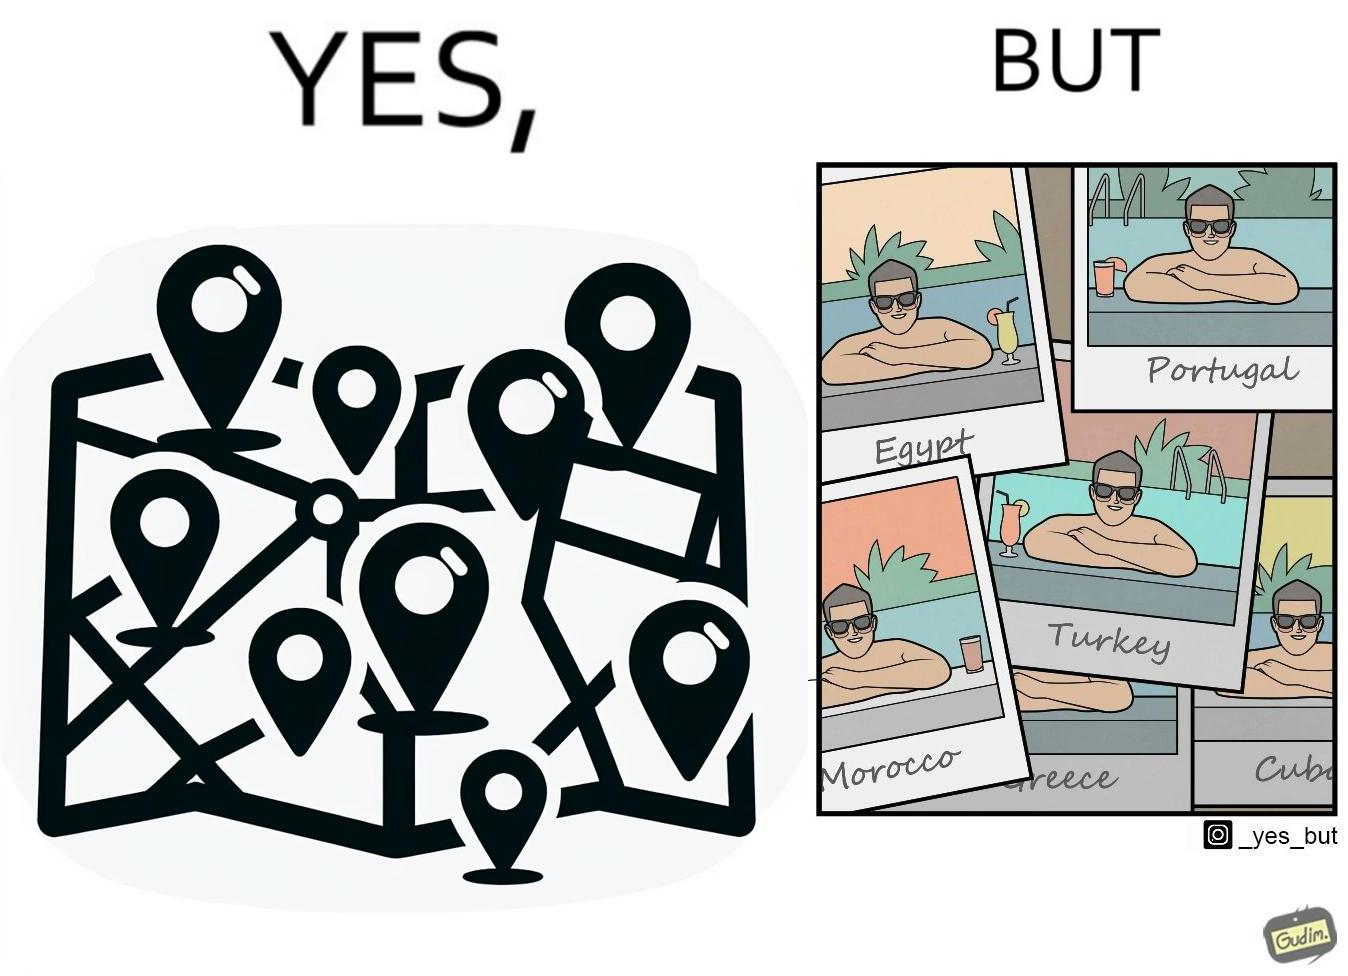What is the satirical meaning behind this image? The image is satirical because while the man has visited all the place marked on the map, he only seems to have swam in pools in all these differnt countries and has not actually seen these places. 